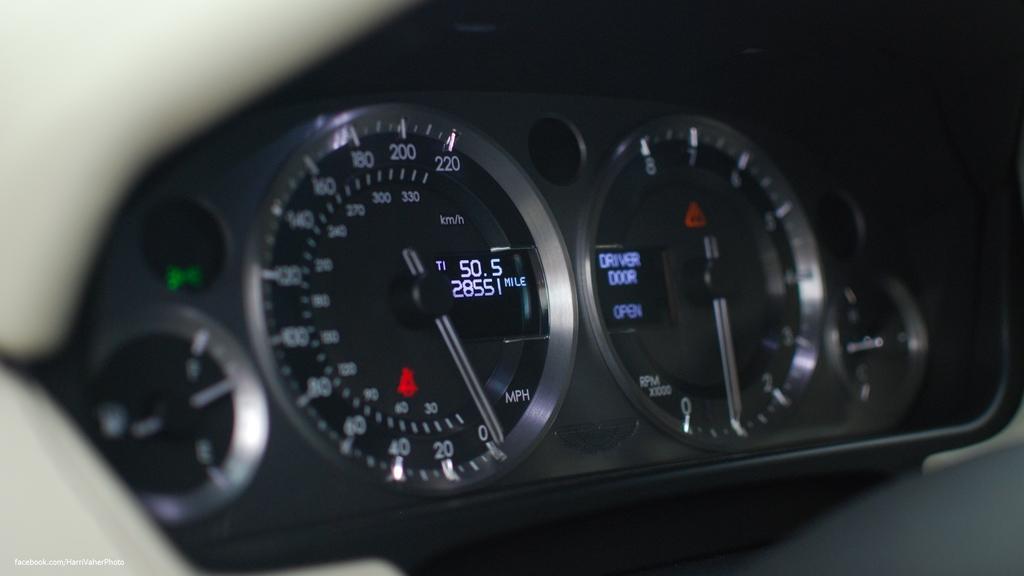How would you summarize this image in a sentence or two? In this image we can see there is a digital meter of a vehicle. 